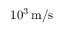Convert formula to latex. <formula><loc_0><loc_0><loc_500><loc_500>1 0 ^ { 3 } \, m / s</formula> 